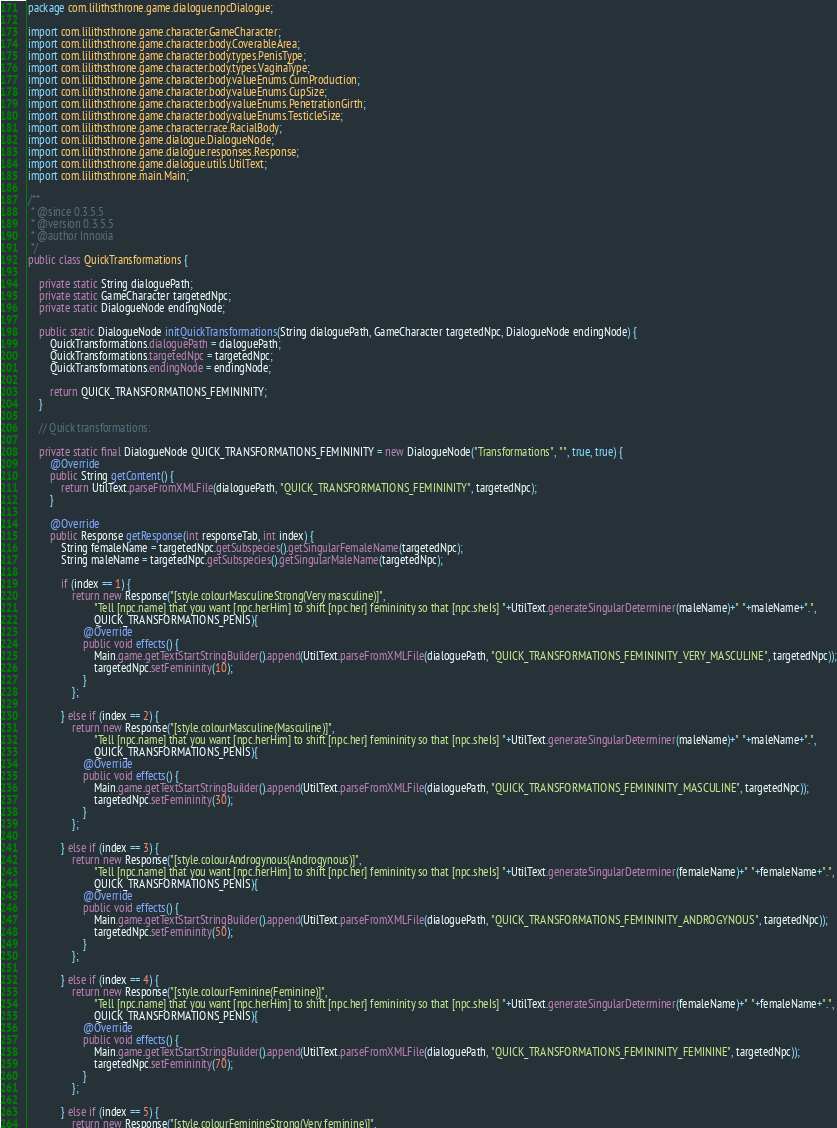Convert code to text. <code><loc_0><loc_0><loc_500><loc_500><_Java_>package com.lilithsthrone.game.dialogue.npcDialogue;
import com.lilithsthrone.game.character.GameCharacter;
import com.lilithsthrone.game.character.body.CoverableArea;
import com.lilithsthrone.game.character.body.types.PenisType;
import com.lilithsthrone.game.character.body.types.VaginaType;
import com.lilithsthrone.game.character.body.valueEnums.CumProduction;
import com.lilithsthrone.game.character.body.valueEnums.CupSize;
import com.lilithsthrone.game.character.body.valueEnums.PenetrationGirth;
import com.lilithsthrone.game.character.body.valueEnums.TesticleSize;
import com.lilithsthrone.game.character.race.RacialBody;
import com.lilithsthrone.game.dialogue.DialogueNode;
import com.lilithsthrone.game.dialogue.responses.Response;
import com.lilithsthrone.game.dialogue.utils.UtilText;
import com.lilithsthrone.main.Main;

/**
 * @since 0.3.5.5
 * @version 0.3.5.5
 * @author Innoxia
 */
public class QuickTransformations {
	
	private static String dialoguePath;
	private static GameCharacter targetedNpc;
	private static DialogueNode endingNode;
	
	public static DialogueNode initQuickTransformations(String dialoguePath, GameCharacter targetedNpc, DialogueNode endingNode) {
		QuickTransformations.dialoguePath = dialoguePath;
		QuickTransformations.targetedNpc = targetedNpc;
		QuickTransformations.endingNode = endingNode;
		
		return QUICK_TRANSFORMATIONS_FEMININITY;
	}
	
	// Quick transformations:
	
	private static final DialogueNode QUICK_TRANSFORMATIONS_FEMININITY = new DialogueNode("Transformations", "", true, true) {
		@Override
		public String getContent() {
			return UtilText.parseFromXMLFile(dialoguePath, "QUICK_TRANSFORMATIONS_FEMININITY", targetedNpc);
		}
		
		@Override
		public Response getResponse(int responseTab, int index) {
			String femaleName = targetedNpc.getSubspecies().getSingularFemaleName(targetedNpc);
			String maleName = targetedNpc.getSubspecies().getSingularMaleName(targetedNpc);
			
			if (index == 1) {
				return new Response("[style.colourMasculineStrong(Very masculine)]",
						"Tell [npc.name] that you want [npc.herHim] to shift [npc.her] femininity so that [npc.sheIs] "+UtilText.generateSingularDeterminer(maleName)+" "+maleName+".",
						QUICK_TRANSFORMATIONS_PENIS){
					@Override
					public void effects() {
						Main.game.getTextStartStringBuilder().append(UtilText.parseFromXMLFile(dialoguePath, "QUICK_TRANSFORMATIONS_FEMININITY_VERY_MASCULINE", targetedNpc));
						targetedNpc.setFemininity(10);
					}
				};
				
			} else if (index == 2) {
				return new Response("[style.colourMasculine(Masculine)]",
						"Tell [npc.name] that you want [npc.herHim] to shift [npc.her] femininity so that [npc.sheIs] "+UtilText.generateSingularDeterminer(maleName)+" "+maleName+".",
						QUICK_TRANSFORMATIONS_PENIS){
					@Override
					public void effects() {
						Main.game.getTextStartStringBuilder().append(UtilText.parseFromXMLFile(dialoguePath, "QUICK_TRANSFORMATIONS_FEMININITY_MASCULINE", targetedNpc));
						targetedNpc.setFemininity(30);
					}
				};
				
			} else if (index == 3) {
				return new Response("[style.colourAndrogynous(Androgynous)]",
						"Tell [npc.name] that you want [npc.herHim] to shift [npc.her] femininity so that [npc.sheIs] "+UtilText.generateSingularDeterminer(femaleName)+" "+femaleName+".",
						QUICK_TRANSFORMATIONS_PENIS){
					@Override
					public void effects() {
						Main.game.getTextStartStringBuilder().append(UtilText.parseFromXMLFile(dialoguePath, "QUICK_TRANSFORMATIONS_FEMININITY_ANDROGYNOUS", targetedNpc));
						targetedNpc.setFemininity(50);
					}
				};
				
			} else if (index == 4) {
				return new Response("[style.colourFeminine(Feminine)]",
						"Tell [npc.name] that you want [npc.herHim] to shift [npc.her] femininity so that [npc.sheIs] "+UtilText.generateSingularDeterminer(femaleName)+" "+femaleName+".",
						QUICK_TRANSFORMATIONS_PENIS){
					@Override
					public void effects() {
						Main.game.getTextStartStringBuilder().append(UtilText.parseFromXMLFile(dialoguePath, "QUICK_TRANSFORMATIONS_FEMININITY_FEMININE", targetedNpc));
						targetedNpc.setFemininity(70);
					}
				};
				
			} else if (index == 5) {
				return new Response("[style.colourFeminineStrong(Very feminine)]",</code> 